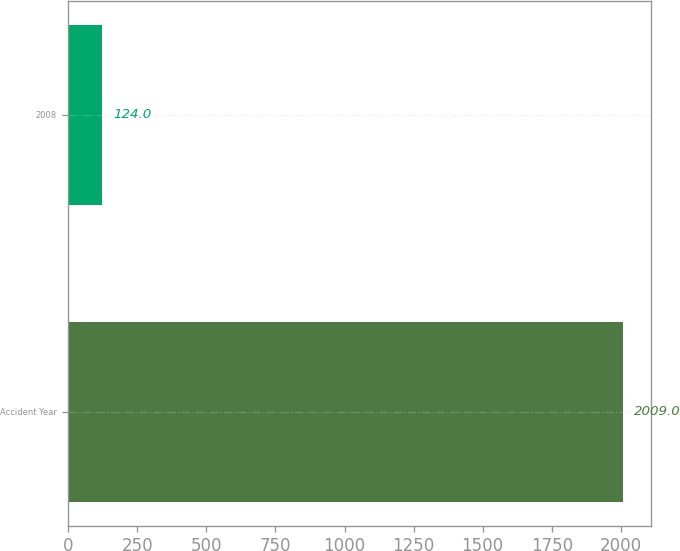Convert chart to OTSL. <chart><loc_0><loc_0><loc_500><loc_500><bar_chart><fcel>Accident Year<fcel>2008<nl><fcel>2009<fcel>124<nl></chart> 